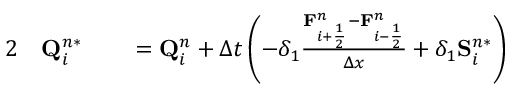Convert formula to latex. <formula><loc_0><loc_0><loc_500><loc_500>\begin{array} { r l r l } { 2 } & Q _ { i } ^ { n * } } & = Q _ { i } ^ { n } + \Delta t \left ( - \delta _ { 1 } \frac { F _ { i + \frac { 1 } { 2 } } ^ { n } - F _ { i - \frac { 1 } { 2 } } ^ { n } } { \Delta x } + \delta _ { 1 } S _ { i } ^ { n * } \right ) } \end{array}</formula> 